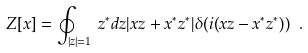<formula> <loc_0><loc_0><loc_500><loc_500>Z [ x ] = \oint _ { | z | = 1 } \, z ^ { * } d z | x z + x ^ { * } z ^ { * } | \delta ( i ( x z - x ^ { * } z ^ { * } ) ) \ .</formula> 